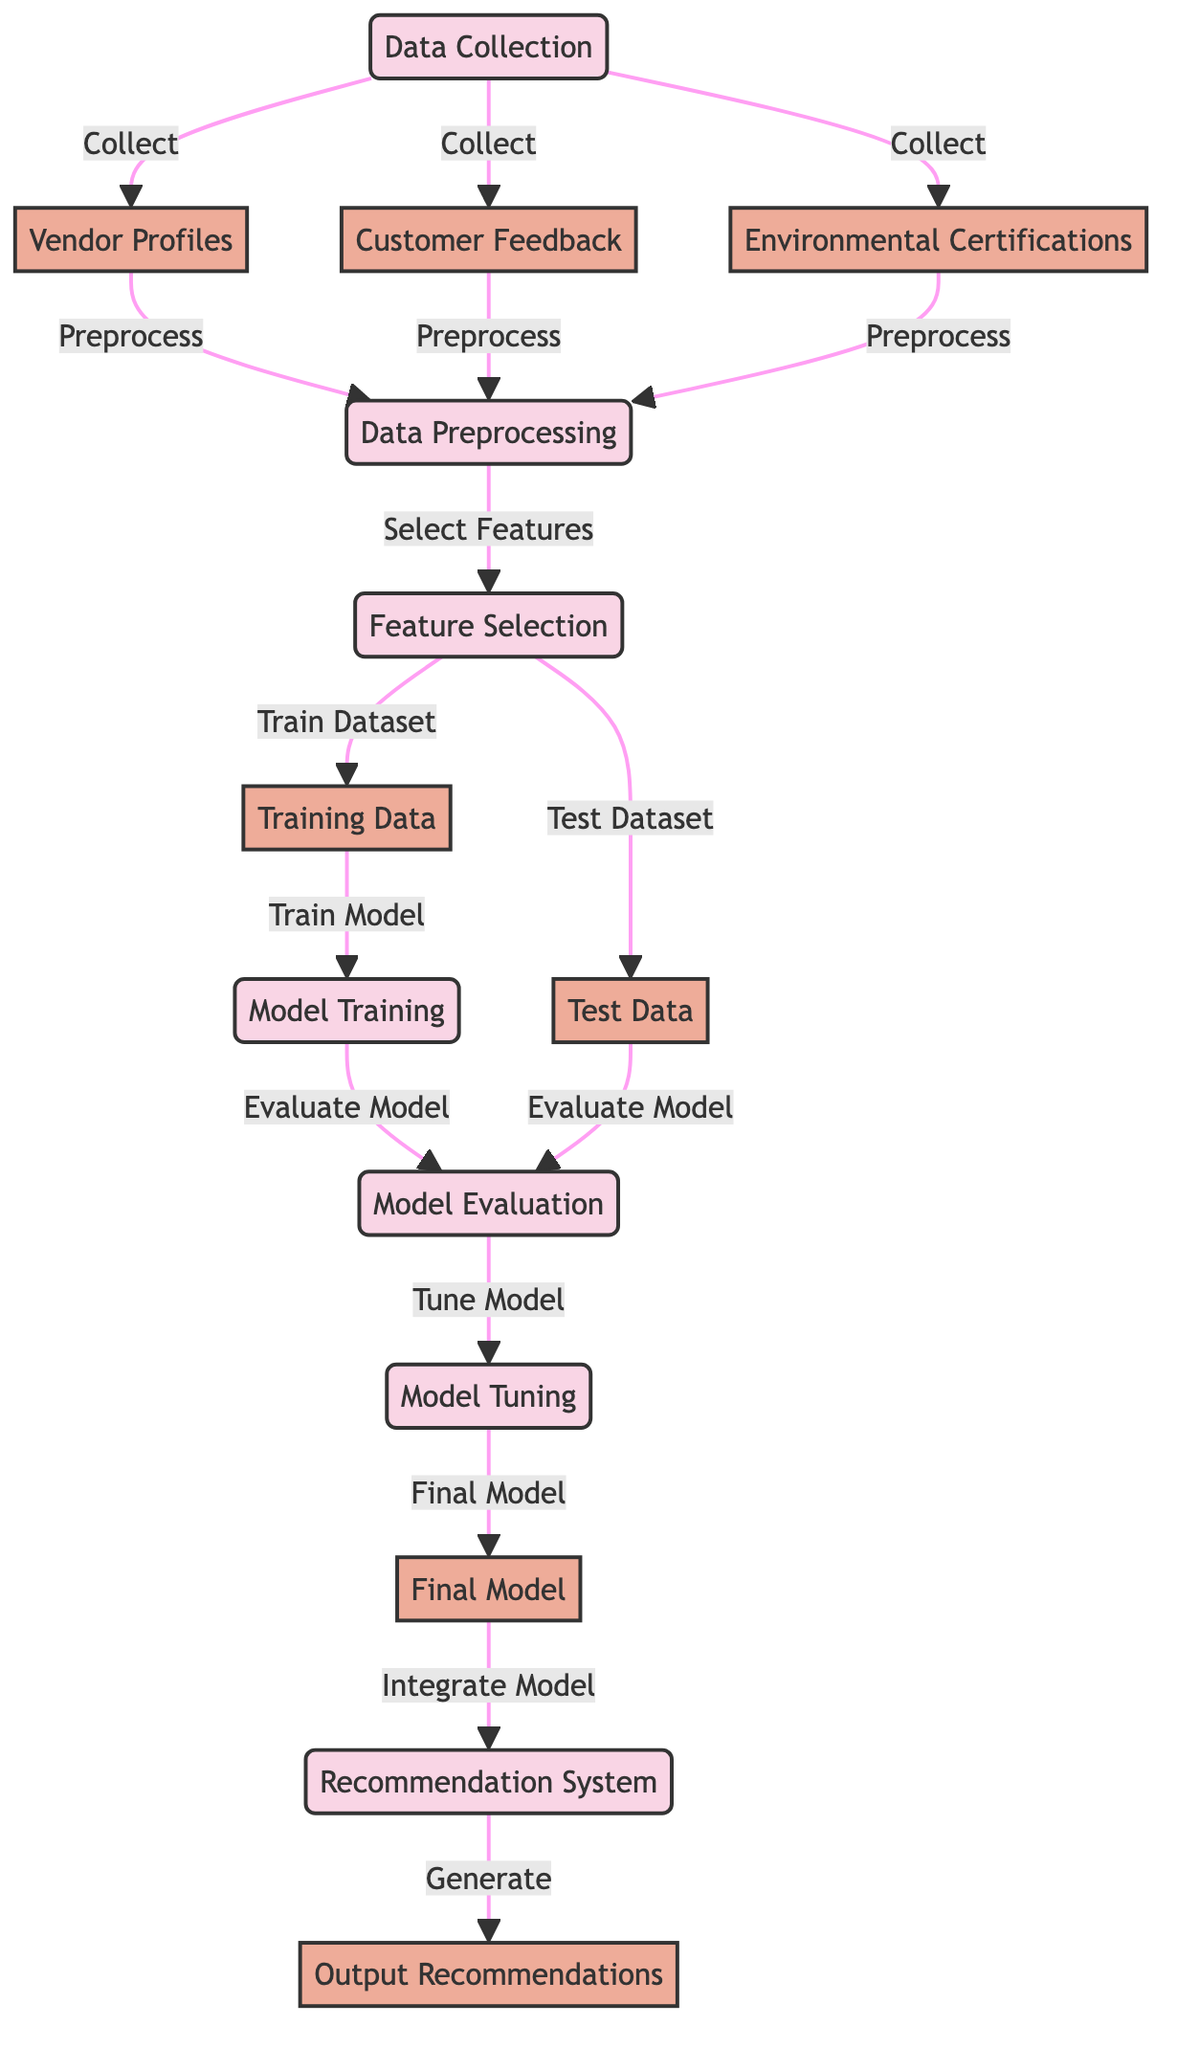What are the three main types of data collected? The diagram indicates that vendor profiles, customer feedback, and environmental certifications are the three main types of data collected during the data collection phase.
Answer: vendor profiles, customer feedback, environmental certifications What comes after data preprocessing? The diagram shows that after the data preprocessing step, the next steps are feature selection, where features are selected from the preprocessed data.
Answer: feature selection How many nodes are in the diagram? By counting each labeled node in the diagram, we determine that there are 12 nodes representing various steps and data types.
Answer: twelve What connects customer feedback and environmental certifications to data preprocessing? The diagram illustrates that both customer feedback and environmental certifications, along with vendor profiles, connect to the data preprocessing step, indicating they are inputs to this stage.
Answer: preprocess What is the final output produced by the recommendation system? The output of the recommendation system is described in the diagram as output recommendations, which indicates it generates recommendations for users.
Answer: output recommendations How does the model evaluate its performance? According to the diagram, the evaluation of the model’s performance occurs after model training, where the model is assessed using the test data created during feature selection.
Answer: evaluate model What is the purpose of model tuning in the process? The diagram states that model tuning is a step where the best parameters and settings are refined to enhance the model's performance before it becomes the final model.
Answer: tune model What does the data preprocessing node connect to? The data preprocessing node connects specifically to the feature selection node, indicating that the next step after preprocessing is to select relevant features for the model.
Answer: feature selection How do we obtain the training data? The diagram indicates that the training data is obtained from the feature selection process, where the selected features are used to create the training dataset.
Answer: train dataset 